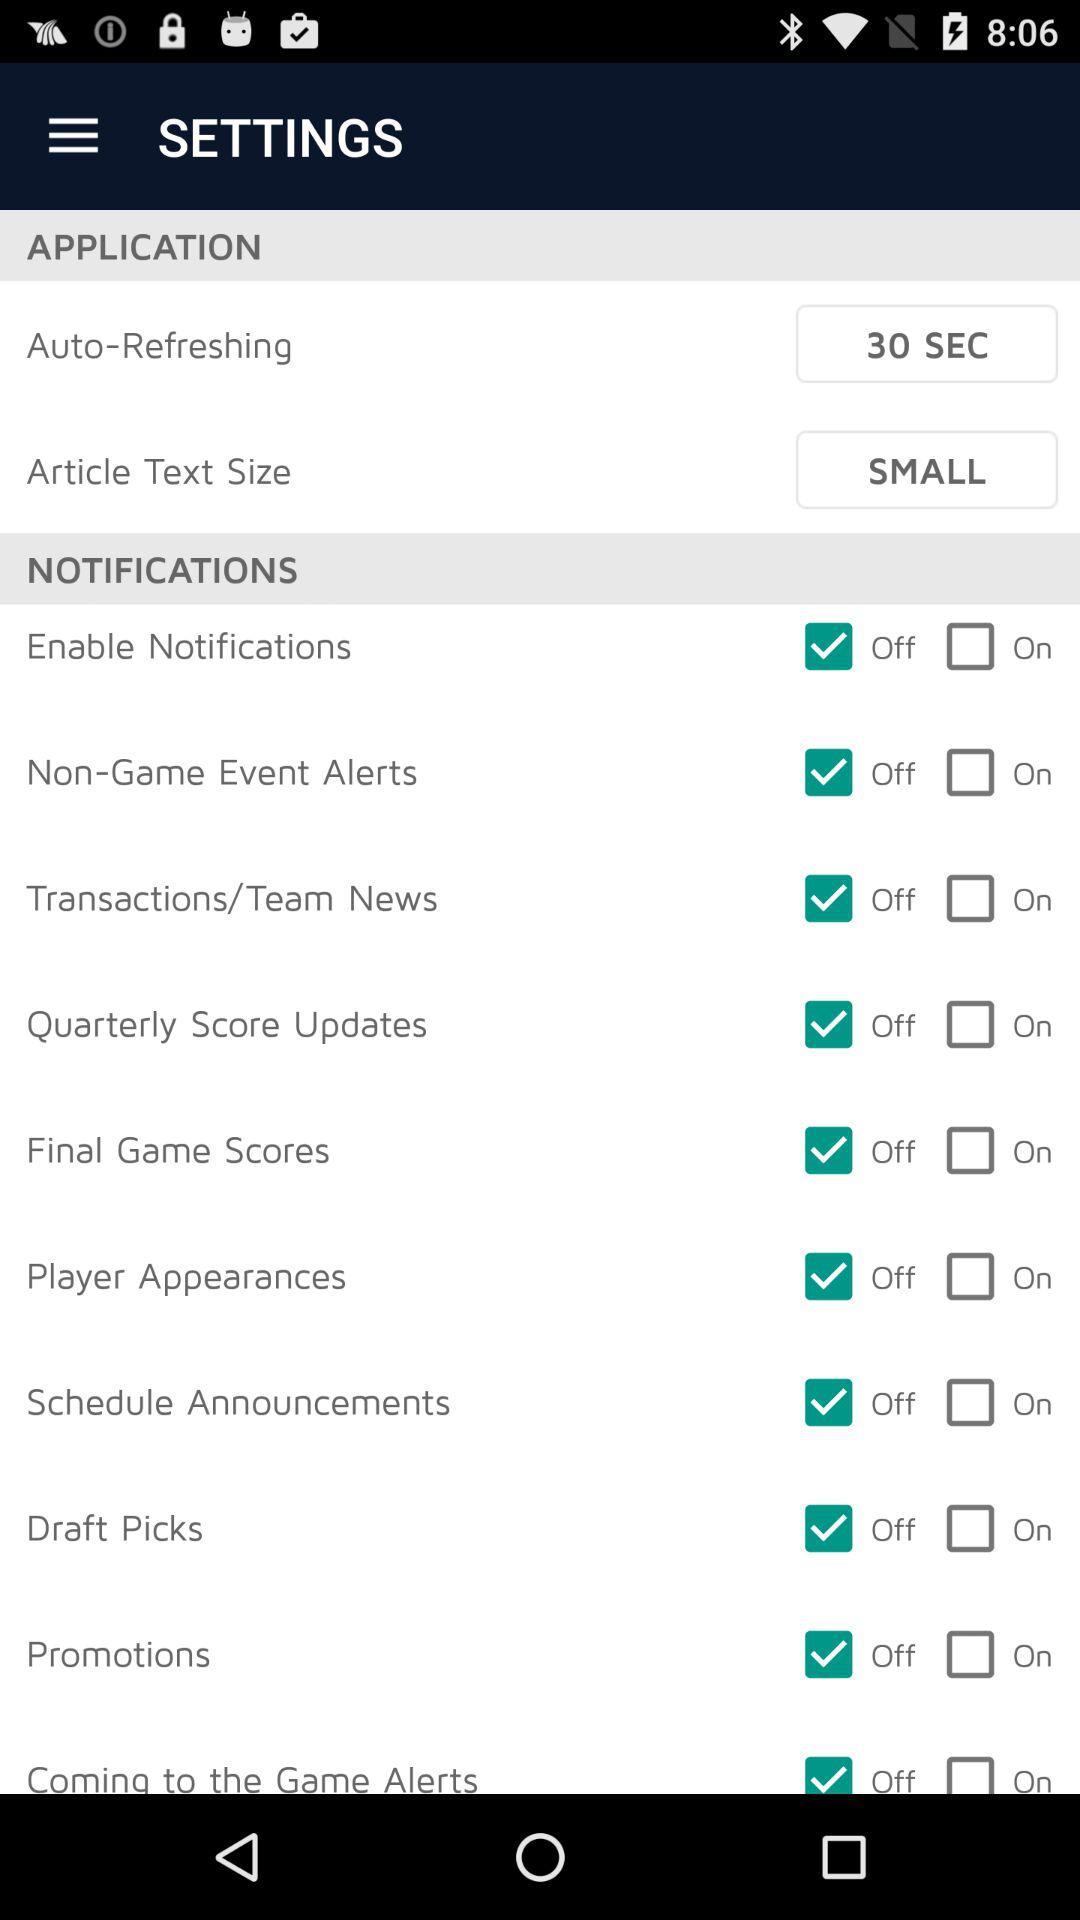What is the "Article Text Size"? The "Article Text Size" is "SMALL". 